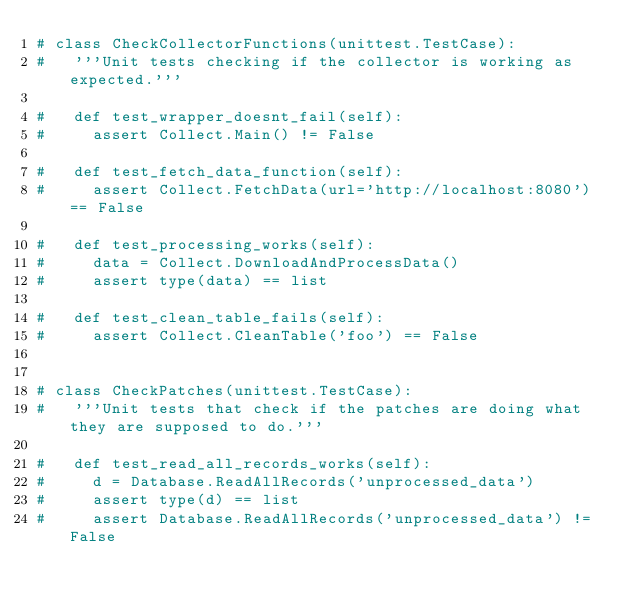Convert code to text. <code><loc_0><loc_0><loc_500><loc_500><_Python_># class CheckCollectorFunctions(unittest.TestCase):
#   '''Unit tests checking if the collector is working as expected.'''

#   def test_wrapper_doesnt_fail(self):
#     assert Collect.Main() != False

#   def test_fetch_data_function(self):
#     assert Collect.FetchData(url='http://localhost:8080') == False

#   def test_processing_works(self):
#     data = Collect.DownloadAndProcessData()
#     assert type(data) == list

#   def test_clean_table_fails(self):
#     assert Collect.CleanTable('foo') == False


# class CheckPatches(unittest.TestCase):
#   '''Unit tests that check if the patches are doing what they are supposed to do.'''

#   def test_read_all_records_works(self):
#     d = Database.ReadAllRecords('unprocessed_data')
#     assert type(d) == list
#     assert Database.ReadAllRecords('unprocessed_data') != False
</code> 